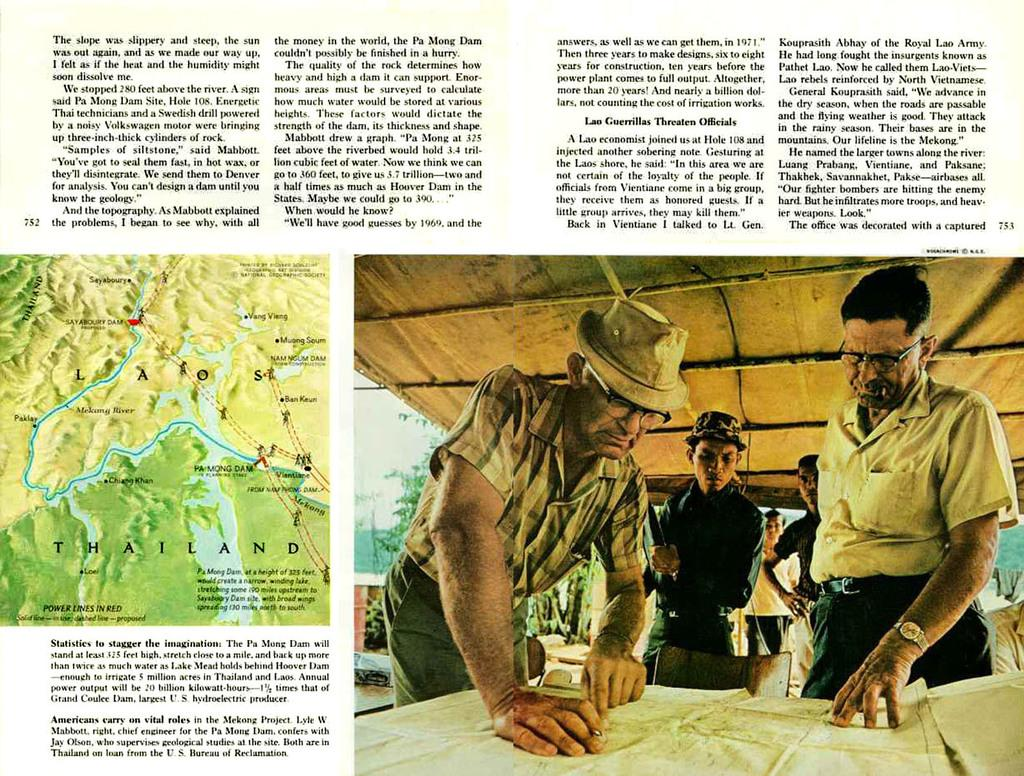What type of content is present in the image? There is some text, a map, and a picture in the image. Can you describe the picture in the image? The picture contains people. What other type of content can be found in the image besides the picture? There is a map in the image. What might the text in the image be used for? The text in the image might provide additional information or context. How many boats are visible in the image? There are no boats present in the image. What type of ducks can be seen swimming in the picture? There are no ducks present in the image. 